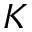Convert formula to latex. <formula><loc_0><loc_0><loc_500><loc_500>K</formula> 